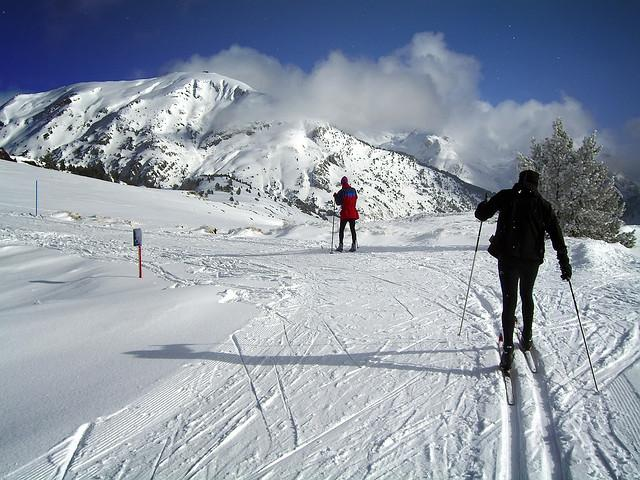What is misting up from the mountain?

Choices:
A) man's breath
B) city smog
C) smoke
D) fog fog 